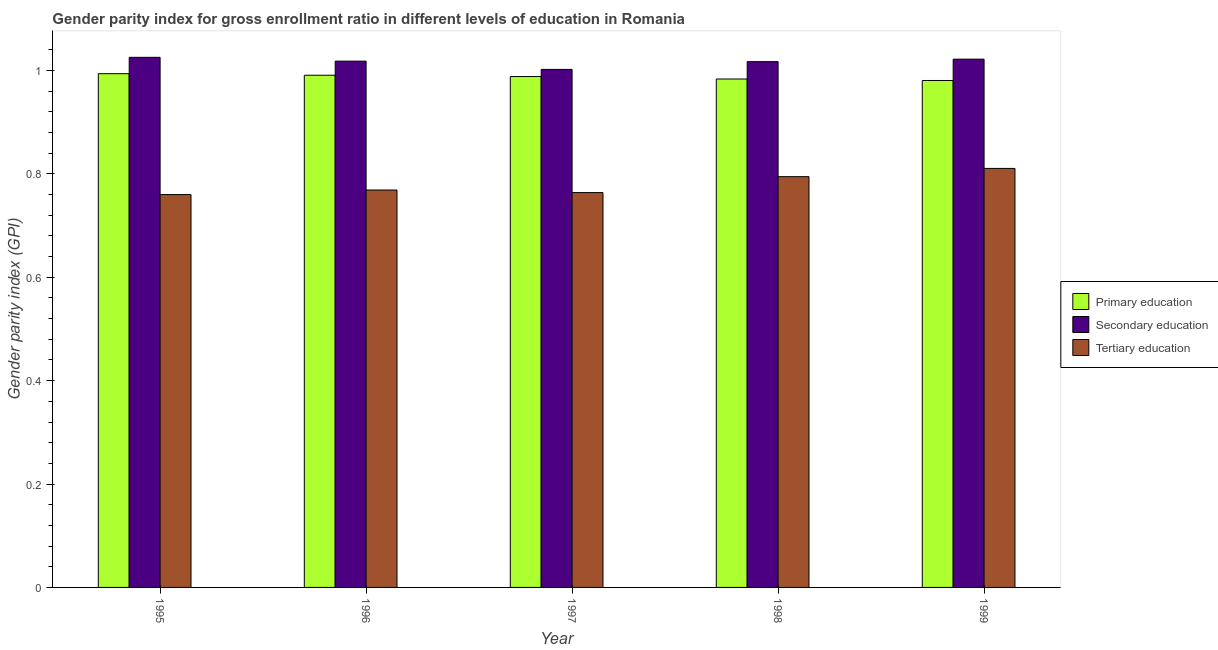How many different coloured bars are there?
Provide a short and direct response. 3. How many groups of bars are there?
Provide a short and direct response. 5. Are the number of bars per tick equal to the number of legend labels?
Provide a succinct answer. Yes. Are the number of bars on each tick of the X-axis equal?
Give a very brief answer. Yes. How many bars are there on the 4th tick from the left?
Provide a succinct answer. 3. What is the gender parity index in secondary education in 1998?
Your answer should be very brief. 1.02. Across all years, what is the maximum gender parity index in secondary education?
Provide a succinct answer. 1.03. Across all years, what is the minimum gender parity index in tertiary education?
Give a very brief answer. 0.76. In which year was the gender parity index in primary education maximum?
Your answer should be compact. 1995. In which year was the gender parity index in secondary education minimum?
Offer a terse response. 1997. What is the total gender parity index in primary education in the graph?
Make the answer very short. 4.94. What is the difference between the gender parity index in tertiary education in 1995 and that in 1996?
Provide a succinct answer. -0.01. What is the difference between the gender parity index in primary education in 1996 and the gender parity index in secondary education in 1998?
Keep it short and to the point. 0.01. What is the average gender parity index in tertiary education per year?
Your response must be concise. 0.78. In the year 1998, what is the difference between the gender parity index in secondary education and gender parity index in primary education?
Ensure brevity in your answer.  0. What is the ratio of the gender parity index in primary education in 1996 to that in 1999?
Make the answer very short. 1.01. Is the gender parity index in secondary education in 1995 less than that in 1998?
Make the answer very short. No. What is the difference between the highest and the second highest gender parity index in secondary education?
Keep it short and to the point. 0. What is the difference between the highest and the lowest gender parity index in tertiary education?
Keep it short and to the point. 0.05. In how many years, is the gender parity index in secondary education greater than the average gender parity index in secondary education taken over all years?
Keep it short and to the point. 4. Is the sum of the gender parity index in secondary education in 1996 and 1997 greater than the maximum gender parity index in primary education across all years?
Your answer should be very brief. Yes. What does the 3rd bar from the left in 1995 represents?
Your answer should be very brief. Tertiary education. What does the 1st bar from the right in 1997 represents?
Your answer should be compact. Tertiary education. Are all the bars in the graph horizontal?
Your response must be concise. No. How many years are there in the graph?
Provide a short and direct response. 5. What is the difference between two consecutive major ticks on the Y-axis?
Keep it short and to the point. 0.2. Are the values on the major ticks of Y-axis written in scientific E-notation?
Give a very brief answer. No. Does the graph contain any zero values?
Give a very brief answer. No. Where does the legend appear in the graph?
Give a very brief answer. Center right. How many legend labels are there?
Provide a succinct answer. 3. How are the legend labels stacked?
Provide a succinct answer. Vertical. What is the title of the graph?
Your response must be concise. Gender parity index for gross enrollment ratio in different levels of education in Romania. What is the label or title of the X-axis?
Provide a succinct answer. Year. What is the label or title of the Y-axis?
Your answer should be compact. Gender parity index (GPI). What is the Gender parity index (GPI) of Primary education in 1995?
Your response must be concise. 0.99. What is the Gender parity index (GPI) in Secondary education in 1995?
Your answer should be compact. 1.03. What is the Gender parity index (GPI) in Tertiary education in 1995?
Ensure brevity in your answer.  0.76. What is the Gender parity index (GPI) in Primary education in 1996?
Your answer should be compact. 0.99. What is the Gender parity index (GPI) in Secondary education in 1996?
Keep it short and to the point. 1.02. What is the Gender parity index (GPI) of Tertiary education in 1996?
Make the answer very short. 0.77. What is the Gender parity index (GPI) in Primary education in 1997?
Offer a very short reply. 0.99. What is the Gender parity index (GPI) of Secondary education in 1997?
Your answer should be very brief. 1. What is the Gender parity index (GPI) in Tertiary education in 1997?
Offer a very short reply. 0.76. What is the Gender parity index (GPI) in Primary education in 1998?
Provide a succinct answer. 0.98. What is the Gender parity index (GPI) in Secondary education in 1998?
Offer a very short reply. 1.02. What is the Gender parity index (GPI) of Tertiary education in 1998?
Provide a short and direct response. 0.79. What is the Gender parity index (GPI) of Primary education in 1999?
Ensure brevity in your answer.  0.98. What is the Gender parity index (GPI) of Secondary education in 1999?
Keep it short and to the point. 1.02. What is the Gender parity index (GPI) of Tertiary education in 1999?
Provide a succinct answer. 0.81. Across all years, what is the maximum Gender parity index (GPI) of Primary education?
Your answer should be very brief. 0.99. Across all years, what is the maximum Gender parity index (GPI) in Secondary education?
Provide a succinct answer. 1.03. Across all years, what is the maximum Gender parity index (GPI) of Tertiary education?
Provide a short and direct response. 0.81. Across all years, what is the minimum Gender parity index (GPI) in Primary education?
Offer a very short reply. 0.98. Across all years, what is the minimum Gender parity index (GPI) in Secondary education?
Give a very brief answer. 1. Across all years, what is the minimum Gender parity index (GPI) of Tertiary education?
Your answer should be very brief. 0.76. What is the total Gender parity index (GPI) in Primary education in the graph?
Your response must be concise. 4.94. What is the total Gender parity index (GPI) of Secondary education in the graph?
Provide a short and direct response. 5.08. What is the total Gender parity index (GPI) of Tertiary education in the graph?
Provide a succinct answer. 3.9. What is the difference between the Gender parity index (GPI) of Primary education in 1995 and that in 1996?
Your answer should be very brief. 0. What is the difference between the Gender parity index (GPI) of Secondary education in 1995 and that in 1996?
Give a very brief answer. 0.01. What is the difference between the Gender parity index (GPI) in Tertiary education in 1995 and that in 1996?
Give a very brief answer. -0.01. What is the difference between the Gender parity index (GPI) of Primary education in 1995 and that in 1997?
Your answer should be very brief. 0.01. What is the difference between the Gender parity index (GPI) of Secondary education in 1995 and that in 1997?
Your answer should be compact. 0.02. What is the difference between the Gender parity index (GPI) of Tertiary education in 1995 and that in 1997?
Ensure brevity in your answer.  -0. What is the difference between the Gender parity index (GPI) of Primary education in 1995 and that in 1998?
Give a very brief answer. 0.01. What is the difference between the Gender parity index (GPI) in Secondary education in 1995 and that in 1998?
Your answer should be very brief. 0.01. What is the difference between the Gender parity index (GPI) in Tertiary education in 1995 and that in 1998?
Your answer should be very brief. -0.03. What is the difference between the Gender parity index (GPI) of Primary education in 1995 and that in 1999?
Provide a succinct answer. 0.01. What is the difference between the Gender parity index (GPI) of Secondary education in 1995 and that in 1999?
Make the answer very short. 0. What is the difference between the Gender parity index (GPI) of Tertiary education in 1995 and that in 1999?
Make the answer very short. -0.05. What is the difference between the Gender parity index (GPI) in Primary education in 1996 and that in 1997?
Keep it short and to the point. 0. What is the difference between the Gender parity index (GPI) of Secondary education in 1996 and that in 1997?
Give a very brief answer. 0.02. What is the difference between the Gender parity index (GPI) in Tertiary education in 1996 and that in 1997?
Your response must be concise. 0.01. What is the difference between the Gender parity index (GPI) in Primary education in 1996 and that in 1998?
Ensure brevity in your answer.  0.01. What is the difference between the Gender parity index (GPI) of Tertiary education in 1996 and that in 1998?
Make the answer very short. -0.03. What is the difference between the Gender parity index (GPI) of Primary education in 1996 and that in 1999?
Offer a terse response. 0.01. What is the difference between the Gender parity index (GPI) of Secondary education in 1996 and that in 1999?
Ensure brevity in your answer.  -0. What is the difference between the Gender parity index (GPI) in Tertiary education in 1996 and that in 1999?
Give a very brief answer. -0.04. What is the difference between the Gender parity index (GPI) of Primary education in 1997 and that in 1998?
Keep it short and to the point. 0. What is the difference between the Gender parity index (GPI) of Secondary education in 1997 and that in 1998?
Ensure brevity in your answer.  -0.01. What is the difference between the Gender parity index (GPI) of Tertiary education in 1997 and that in 1998?
Keep it short and to the point. -0.03. What is the difference between the Gender parity index (GPI) in Primary education in 1997 and that in 1999?
Your answer should be compact. 0.01. What is the difference between the Gender parity index (GPI) of Secondary education in 1997 and that in 1999?
Your answer should be compact. -0.02. What is the difference between the Gender parity index (GPI) in Tertiary education in 1997 and that in 1999?
Your answer should be compact. -0.05. What is the difference between the Gender parity index (GPI) of Primary education in 1998 and that in 1999?
Your answer should be compact. 0. What is the difference between the Gender parity index (GPI) in Secondary education in 1998 and that in 1999?
Provide a short and direct response. -0. What is the difference between the Gender parity index (GPI) in Tertiary education in 1998 and that in 1999?
Offer a terse response. -0.02. What is the difference between the Gender parity index (GPI) of Primary education in 1995 and the Gender parity index (GPI) of Secondary education in 1996?
Your answer should be compact. -0.02. What is the difference between the Gender parity index (GPI) in Primary education in 1995 and the Gender parity index (GPI) in Tertiary education in 1996?
Your response must be concise. 0.23. What is the difference between the Gender parity index (GPI) of Secondary education in 1995 and the Gender parity index (GPI) of Tertiary education in 1996?
Keep it short and to the point. 0.26. What is the difference between the Gender parity index (GPI) of Primary education in 1995 and the Gender parity index (GPI) of Secondary education in 1997?
Offer a terse response. -0.01. What is the difference between the Gender parity index (GPI) of Primary education in 1995 and the Gender parity index (GPI) of Tertiary education in 1997?
Provide a short and direct response. 0.23. What is the difference between the Gender parity index (GPI) of Secondary education in 1995 and the Gender parity index (GPI) of Tertiary education in 1997?
Make the answer very short. 0.26. What is the difference between the Gender parity index (GPI) of Primary education in 1995 and the Gender parity index (GPI) of Secondary education in 1998?
Offer a very short reply. -0.02. What is the difference between the Gender parity index (GPI) of Primary education in 1995 and the Gender parity index (GPI) of Tertiary education in 1998?
Make the answer very short. 0.2. What is the difference between the Gender parity index (GPI) of Secondary education in 1995 and the Gender parity index (GPI) of Tertiary education in 1998?
Offer a very short reply. 0.23. What is the difference between the Gender parity index (GPI) in Primary education in 1995 and the Gender parity index (GPI) in Secondary education in 1999?
Make the answer very short. -0.03. What is the difference between the Gender parity index (GPI) in Primary education in 1995 and the Gender parity index (GPI) in Tertiary education in 1999?
Your answer should be very brief. 0.18. What is the difference between the Gender parity index (GPI) in Secondary education in 1995 and the Gender parity index (GPI) in Tertiary education in 1999?
Give a very brief answer. 0.21. What is the difference between the Gender parity index (GPI) in Primary education in 1996 and the Gender parity index (GPI) in Secondary education in 1997?
Give a very brief answer. -0.01. What is the difference between the Gender parity index (GPI) of Primary education in 1996 and the Gender parity index (GPI) of Tertiary education in 1997?
Your answer should be compact. 0.23. What is the difference between the Gender parity index (GPI) of Secondary education in 1996 and the Gender parity index (GPI) of Tertiary education in 1997?
Provide a short and direct response. 0.25. What is the difference between the Gender parity index (GPI) of Primary education in 1996 and the Gender parity index (GPI) of Secondary education in 1998?
Offer a terse response. -0.03. What is the difference between the Gender parity index (GPI) in Primary education in 1996 and the Gender parity index (GPI) in Tertiary education in 1998?
Offer a very short reply. 0.2. What is the difference between the Gender parity index (GPI) of Secondary education in 1996 and the Gender parity index (GPI) of Tertiary education in 1998?
Offer a very short reply. 0.22. What is the difference between the Gender parity index (GPI) of Primary education in 1996 and the Gender parity index (GPI) of Secondary education in 1999?
Your answer should be compact. -0.03. What is the difference between the Gender parity index (GPI) of Primary education in 1996 and the Gender parity index (GPI) of Tertiary education in 1999?
Offer a very short reply. 0.18. What is the difference between the Gender parity index (GPI) of Secondary education in 1996 and the Gender parity index (GPI) of Tertiary education in 1999?
Provide a succinct answer. 0.21. What is the difference between the Gender parity index (GPI) of Primary education in 1997 and the Gender parity index (GPI) of Secondary education in 1998?
Ensure brevity in your answer.  -0.03. What is the difference between the Gender parity index (GPI) of Primary education in 1997 and the Gender parity index (GPI) of Tertiary education in 1998?
Keep it short and to the point. 0.19. What is the difference between the Gender parity index (GPI) of Secondary education in 1997 and the Gender parity index (GPI) of Tertiary education in 1998?
Offer a terse response. 0.21. What is the difference between the Gender parity index (GPI) of Primary education in 1997 and the Gender parity index (GPI) of Secondary education in 1999?
Keep it short and to the point. -0.03. What is the difference between the Gender parity index (GPI) in Primary education in 1997 and the Gender parity index (GPI) in Tertiary education in 1999?
Keep it short and to the point. 0.18. What is the difference between the Gender parity index (GPI) in Secondary education in 1997 and the Gender parity index (GPI) in Tertiary education in 1999?
Offer a very short reply. 0.19. What is the difference between the Gender parity index (GPI) in Primary education in 1998 and the Gender parity index (GPI) in Secondary education in 1999?
Keep it short and to the point. -0.04. What is the difference between the Gender parity index (GPI) in Primary education in 1998 and the Gender parity index (GPI) in Tertiary education in 1999?
Provide a short and direct response. 0.17. What is the difference between the Gender parity index (GPI) of Secondary education in 1998 and the Gender parity index (GPI) of Tertiary education in 1999?
Give a very brief answer. 0.21. What is the average Gender parity index (GPI) of Primary education per year?
Offer a terse response. 0.99. What is the average Gender parity index (GPI) of Secondary education per year?
Your answer should be very brief. 1.02. What is the average Gender parity index (GPI) of Tertiary education per year?
Provide a short and direct response. 0.78. In the year 1995, what is the difference between the Gender parity index (GPI) of Primary education and Gender parity index (GPI) of Secondary education?
Provide a short and direct response. -0.03. In the year 1995, what is the difference between the Gender parity index (GPI) of Primary education and Gender parity index (GPI) of Tertiary education?
Your answer should be compact. 0.23. In the year 1995, what is the difference between the Gender parity index (GPI) in Secondary education and Gender parity index (GPI) in Tertiary education?
Make the answer very short. 0.27. In the year 1996, what is the difference between the Gender parity index (GPI) of Primary education and Gender parity index (GPI) of Secondary education?
Ensure brevity in your answer.  -0.03. In the year 1996, what is the difference between the Gender parity index (GPI) in Primary education and Gender parity index (GPI) in Tertiary education?
Make the answer very short. 0.22. In the year 1996, what is the difference between the Gender parity index (GPI) of Secondary education and Gender parity index (GPI) of Tertiary education?
Give a very brief answer. 0.25. In the year 1997, what is the difference between the Gender parity index (GPI) in Primary education and Gender parity index (GPI) in Secondary education?
Your answer should be very brief. -0.01. In the year 1997, what is the difference between the Gender parity index (GPI) of Primary education and Gender parity index (GPI) of Tertiary education?
Keep it short and to the point. 0.22. In the year 1997, what is the difference between the Gender parity index (GPI) of Secondary education and Gender parity index (GPI) of Tertiary education?
Offer a terse response. 0.24. In the year 1998, what is the difference between the Gender parity index (GPI) in Primary education and Gender parity index (GPI) in Secondary education?
Provide a short and direct response. -0.03. In the year 1998, what is the difference between the Gender parity index (GPI) of Primary education and Gender parity index (GPI) of Tertiary education?
Offer a terse response. 0.19. In the year 1998, what is the difference between the Gender parity index (GPI) of Secondary education and Gender parity index (GPI) of Tertiary education?
Your answer should be very brief. 0.22. In the year 1999, what is the difference between the Gender parity index (GPI) of Primary education and Gender parity index (GPI) of Secondary education?
Provide a succinct answer. -0.04. In the year 1999, what is the difference between the Gender parity index (GPI) of Primary education and Gender parity index (GPI) of Tertiary education?
Ensure brevity in your answer.  0.17. In the year 1999, what is the difference between the Gender parity index (GPI) of Secondary education and Gender parity index (GPI) of Tertiary education?
Offer a terse response. 0.21. What is the ratio of the Gender parity index (GPI) in Primary education in 1995 to that in 1996?
Make the answer very short. 1. What is the ratio of the Gender parity index (GPI) of Tertiary education in 1995 to that in 1996?
Your response must be concise. 0.99. What is the ratio of the Gender parity index (GPI) in Primary education in 1995 to that in 1997?
Offer a terse response. 1.01. What is the ratio of the Gender parity index (GPI) in Secondary education in 1995 to that in 1997?
Provide a short and direct response. 1.02. What is the ratio of the Gender parity index (GPI) in Primary education in 1995 to that in 1998?
Keep it short and to the point. 1.01. What is the ratio of the Gender parity index (GPI) of Secondary education in 1995 to that in 1998?
Provide a short and direct response. 1.01. What is the ratio of the Gender parity index (GPI) of Tertiary education in 1995 to that in 1998?
Provide a short and direct response. 0.96. What is the ratio of the Gender parity index (GPI) in Primary education in 1995 to that in 1999?
Provide a short and direct response. 1.01. What is the ratio of the Gender parity index (GPI) of Tertiary education in 1995 to that in 1999?
Keep it short and to the point. 0.94. What is the ratio of the Gender parity index (GPI) of Secondary education in 1996 to that in 1997?
Your answer should be compact. 1.02. What is the ratio of the Gender parity index (GPI) of Tertiary education in 1996 to that in 1997?
Ensure brevity in your answer.  1.01. What is the ratio of the Gender parity index (GPI) in Primary education in 1996 to that in 1998?
Your answer should be very brief. 1.01. What is the ratio of the Gender parity index (GPI) in Tertiary education in 1996 to that in 1998?
Keep it short and to the point. 0.97. What is the ratio of the Gender parity index (GPI) of Primary education in 1996 to that in 1999?
Provide a short and direct response. 1.01. What is the ratio of the Gender parity index (GPI) in Tertiary education in 1996 to that in 1999?
Provide a short and direct response. 0.95. What is the ratio of the Gender parity index (GPI) of Primary education in 1997 to that in 1998?
Provide a succinct answer. 1. What is the ratio of the Gender parity index (GPI) in Secondary education in 1997 to that in 1998?
Your answer should be compact. 0.99. What is the ratio of the Gender parity index (GPI) of Tertiary education in 1997 to that in 1998?
Provide a short and direct response. 0.96. What is the ratio of the Gender parity index (GPI) of Primary education in 1997 to that in 1999?
Make the answer very short. 1.01. What is the ratio of the Gender parity index (GPI) in Secondary education in 1997 to that in 1999?
Keep it short and to the point. 0.98. What is the ratio of the Gender parity index (GPI) in Tertiary education in 1997 to that in 1999?
Make the answer very short. 0.94. What is the ratio of the Gender parity index (GPI) in Primary education in 1998 to that in 1999?
Your answer should be compact. 1. What is the ratio of the Gender parity index (GPI) in Secondary education in 1998 to that in 1999?
Make the answer very short. 1. What is the ratio of the Gender parity index (GPI) in Tertiary education in 1998 to that in 1999?
Your answer should be very brief. 0.98. What is the difference between the highest and the second highest Gender parity index (GPI) in Primary education?
Your response must be concise. 0. What is the difference between the highest and the second highest Gender parity index (GPI) of Secondary education?
Keep it short and to the point. 0. What is the difference between the highest and the second highest Gender parity index (GPI) in Tertiary education?
Offer a terse response. 0.02. What is the difference between the highest and the lowest Gender parity index (GPI) of Primary education?
Offer a terse response. 0.01. What is the difference between the highest and the lowest Gender parity index (GPI) in Secondary education?
Ensure brevity in your answer.  0.02. What is the difference between the highest and the lowest Gender parity index (GPI) in Tertiary education?
Offer a terse response. 0.05. 